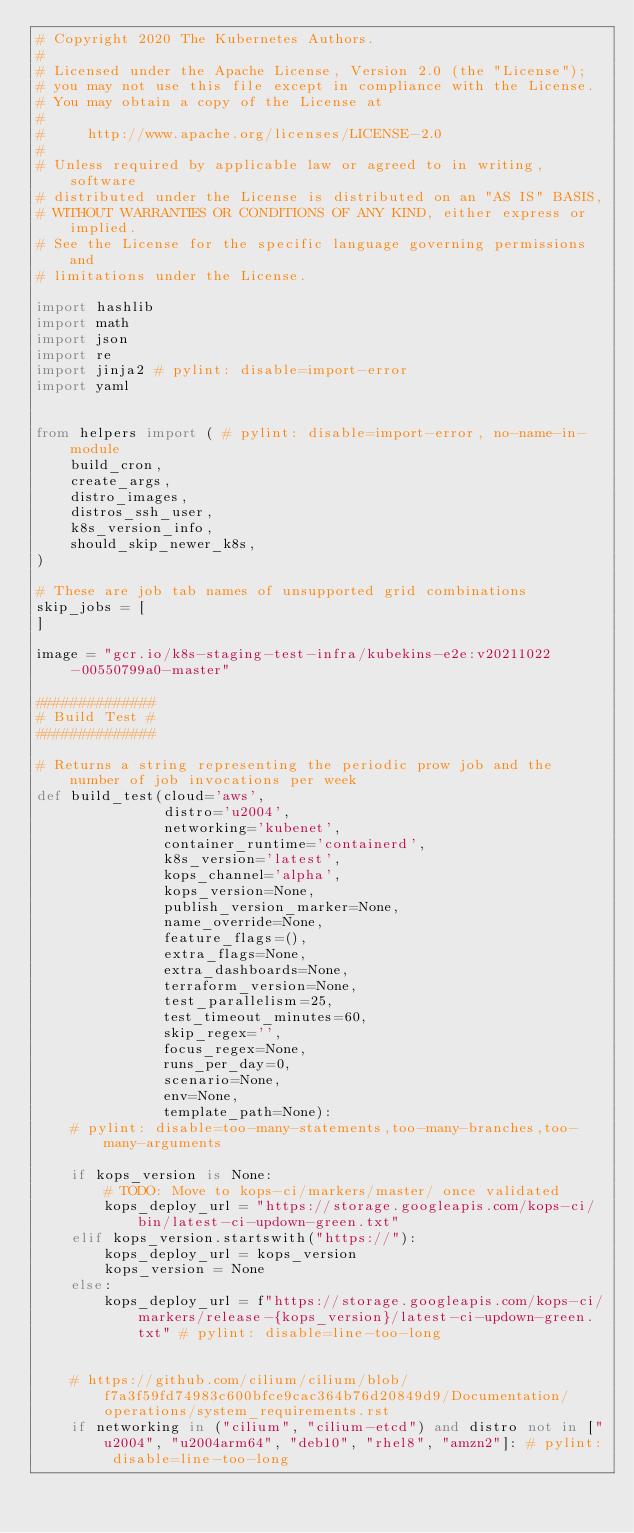Convert code to text. <code><loc_0><loc_0><loc_500><loc_500><_Python_># Copyright 2020 The Kubernetes Authors.
#
# Licensed under the Apache License, Version 2.0 (the "License");
# you may not use this file except in compliance with the License.
# You may obtain a copy of the License at
#
#     http://www.apache.org/licenses/LICENSE-2.0
#
# Unless required by applicable law or agreed to in writing, software
# distributed under the License is distributed on an "AS IS" BASIS,
# WITHOUT WARRANTIES OR CONDITIONS OF ANY KIND, either express or implied.
# See the License for the specific language governing permissions and
# limitations under the License.

import hashlib
import math
import json
import re
import jinja2 # pylint: disable=import-error
import yaml


from helpers import ( # pylint: disable=import-error, no-name-in-module
    build_cron,
    create_args,
    distro_images,
    distros_ssh_user,
    k8s_version_info,
    should_skip_newer_k8s,
)

# These are job tab names of unsupported grid combinations
skip_jobs = [
]

image = "gcr.io/k8s-staging-test-infra/kubekins-e2e:v20211022-00550799a0-master"

##############
# Build Test #
##############

# Returns a string representing the periodic prow job and the number of job invocations per week
def build_test(cloud='aws',
               distro='u2004',
               networking='kubenet',
               container_runtime='containerd',
               k8s_version='latest',
               kops_channel='alpha',
               kops_version=None,
               publish_version_marker=None,
               name_override=None,
               feature_flags=(),
               extra_flags=None,
               extra_dashboards=None,
               terraform_version=None,
               test_parallelism=25,
               test_timeout_minutes=60,
               skip_regex='',
               focus_regex=None,
               runs_per_day=0,
               scenario=None,
               env=None,
               template_path=None):
    # pylint: disable=too-many-statements,too-many-branches,too-many-arguments

    if kops_version is None:
        # TODO: Move to kops-ci/markers/master/ once validated
        kops_deploy_url = "https://storage.googleapis.com/kops-ci/bin/latest-ci-updown-green.txt"
    elif kops_version.startswith("https://"):
        kops_deploy_url = kops_version
        kops_version = None
    else:
        kops_deploy_url = f"https://storage.googleapis.com/kops-ci/markers/release-{kops_version}/latest-ci-updown-green.txt" # pylint: disable=line-too-long


    # https://github.com/cilium/cilium/blob/f7a3f59fd74983c600bfce9cac364b76d20849d9/Documentation/operations/system_requirements.rst
    if networking in ("cilium", "cilium-etcd") and distro not in ["u2004", "u2004arm64", "deb10", "rhel8", "amzn2"]: # pylint: disable=line-too-long</code> 